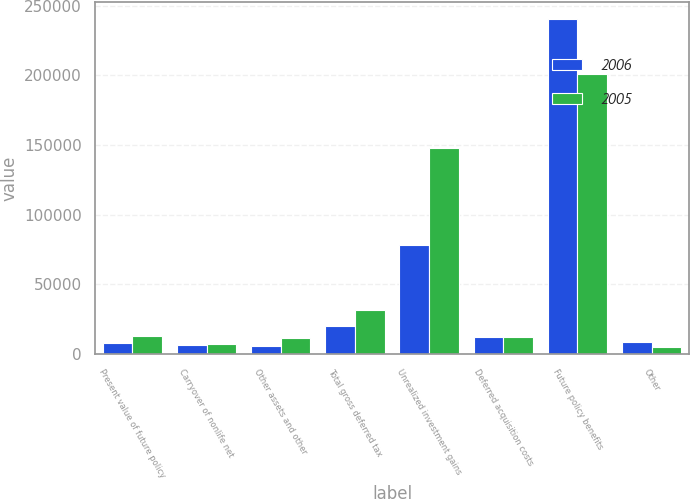Convert chart to OTSL. <chart><loc_0><loc_0><loc_500><loc_500><stacked_bar_chart><ecel><fcel>Present value of future policy<fcel>Carryover of nonlife net<fcel>Other assets and other<fcel>Total gross deferred tax<fcel>Unrealized investment gains<fcel>Deferred acquisition costs<fcel>Future policy benefits<fcel>Other<nl><fcel>2006<fcel>7701<fcel>6801<fcel>5785<fcel>20287<fcel>78055<fcel>12120<fcel>240471<fcel>8385<nl><fcel>2005<fcel>12586<fcel>7105<fcel>11654<fcel>31345<fcel>147507<fcel>12120<fcel>200756<fcel>4762<nl></chart> 